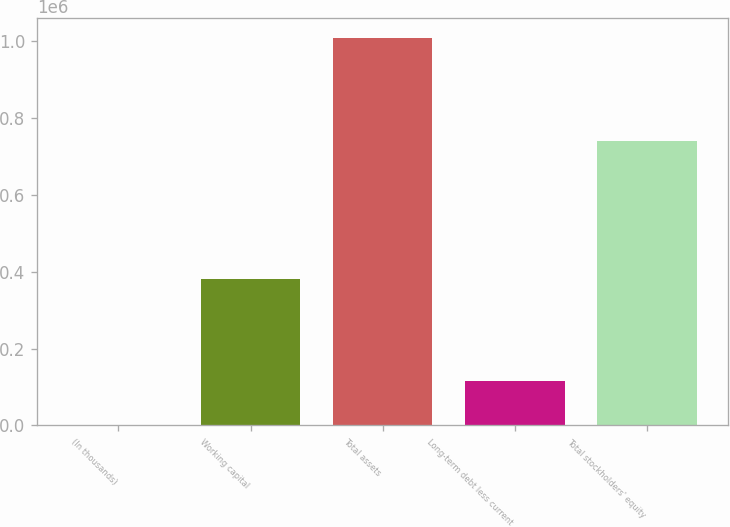Convert chart to OTSL. <chart><loc_0><loc_0><loc_500><loc_500><bar_chart><fcel>(In thousands)<fcel>Working capital<fcel>Total assets<fcel>Long-term debt less current<fcel>Total stockholders' equity<nl><fcel>2006<fcel>381284<fcel>1.00722e+06<fcel>116212<fcel>738148<nl></chart> 